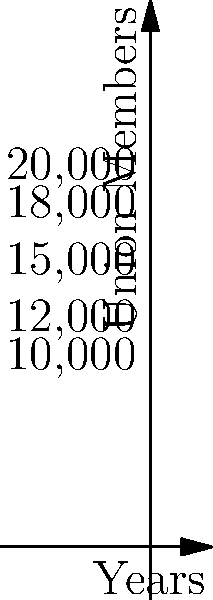As a politician working closely with healthcare labor unions, you're analyzing the growth of a particular union over 5 years. The graph shows the number of union members as a step function. Calculate the total number of member-years (i.e., the area under the curve) for this union over the 5-year period. How does this result inform your understanding of the union's potential impact on healthcare reform efforts? To calculate the total number of member-years, we need to find the area under the step function. We can do this by breaking it down into rectangles and summing their areas:

1. Year 0 to 1: $10,000 \times 1 = 10,000$ member-years
2. Year 1 to 2: $12,000 \times 1 = 12,000$ member-years
3. Year 2 to 3: $15,000 \times 1 = 15,000$ member-years
4. Year 3 to 4: $18,000 \times 1 = 18,000$ member-years
5. Year 4 to 5: $20,000 \times 1 = 20,000$ member-years

Total member-years = $10,000 + 12,000 + 15,000 + 18,000 + 20,000 = 75,000$

Mathematically, this can be represented as an integral of a piecewise function:

$$\int_0^5 f(x) dx = \int_0^1 10000 dx + \int_1^2 12000 dx + \int_2^3 15000 dx + \int_3^4 18000 dx + \int_4^5 20000 dx = 75,000$$

This result shows significant growth and cumulative impact of the union over 5 years. The large number of member-years (75,000) indicates a substantial base for advocating healthcare reform, potentially influencing policy decisions and negotiations.
Answer: 75,000 member-years 